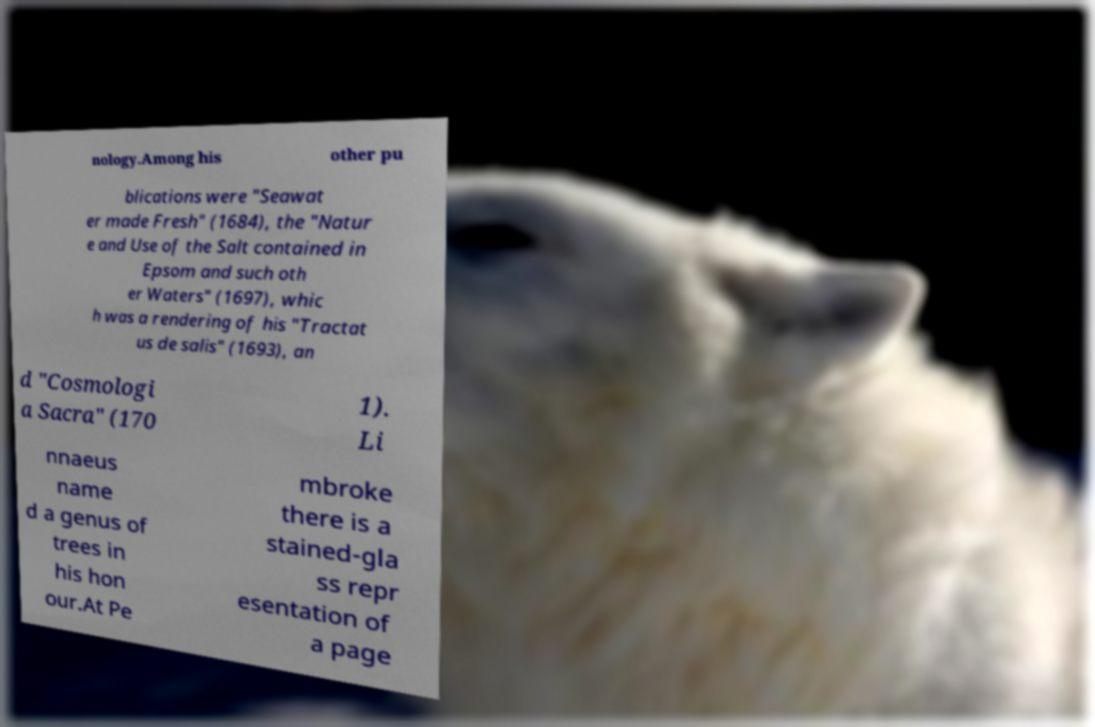Can you read and provide the text displayed in the image?This photo seems to have some interesting text. Can you extract and type it out for me? nology.Among his other pu blications were "Seawat er made Fresh" (1684), the "Natur e and Use of the Salt contained in Epsom and such oth er Waters" (1697), whic h was a rendering of his "Tractat us de salis" (1693), an d "Cosmologi a Sacra" (170 1). Li nnaeus name d a genus of trees in his hon our.At Pe mbroke there is a stained-gla ss repr esentation of a page 